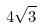Convert formula to latex. <formula><loc_0><loc_0><loc_500><loc_500>4 \sqrt { 3 }</formula> 